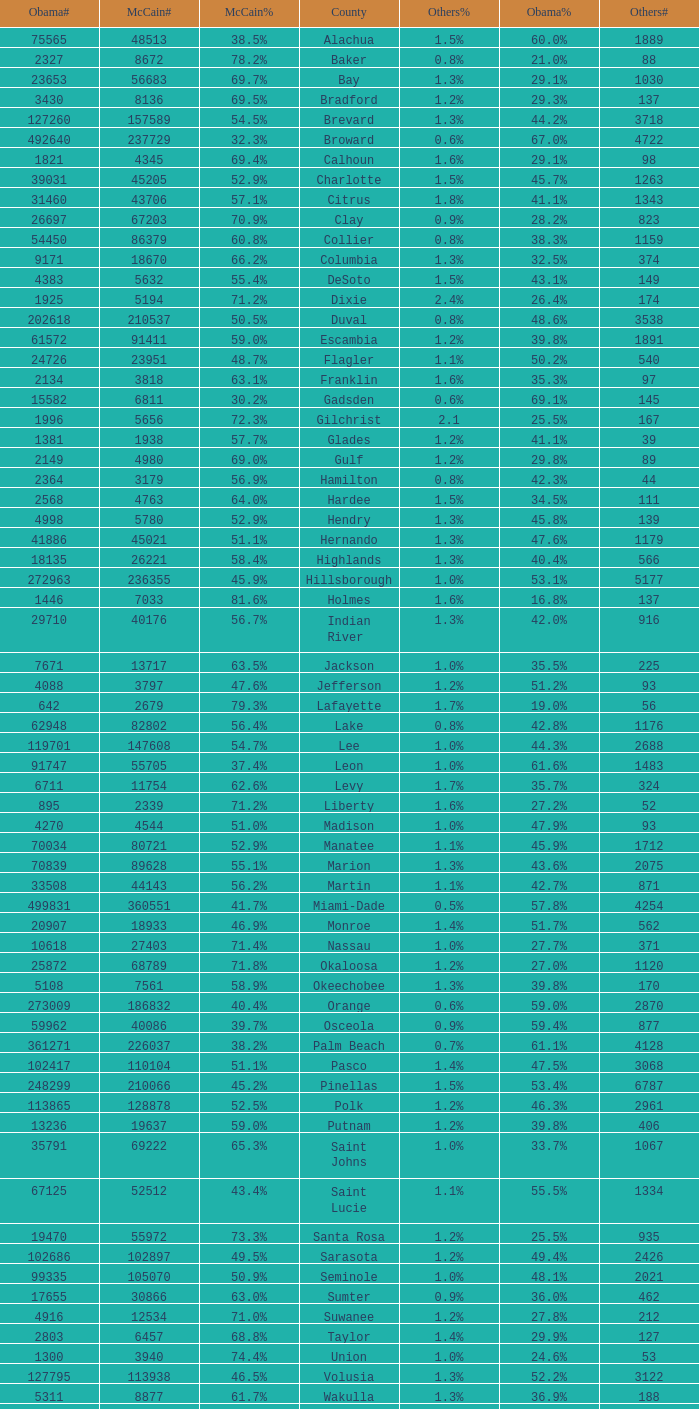How many numbers were recorded under Obama when he had 29.9% voters? 1.0. 